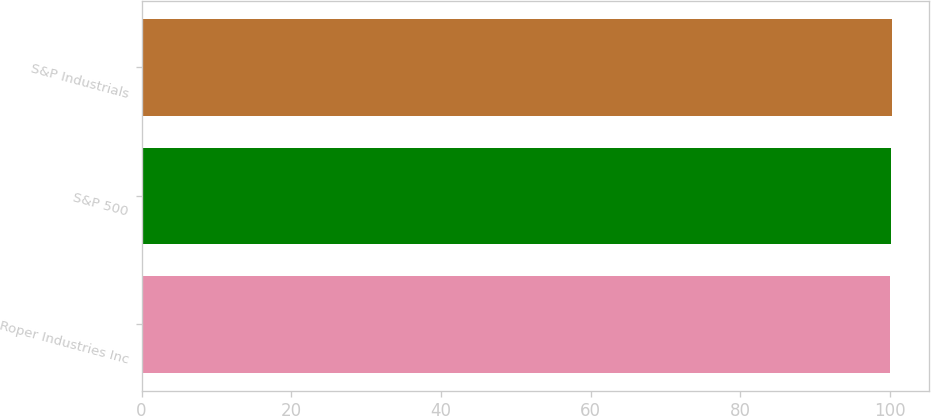<chart> <loc_0><loc_0><loc_500><loc_500><bar_chart><fcel>Roper Industries Inc<fcel>S&P 500<fcel>S&P Industrials<nl><fcel>100<fcel>100.1<fcel>100.2<nl></chart> 